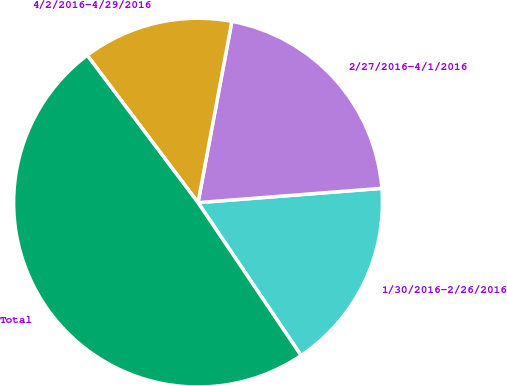Convert chart. <chart><loc_0><loc_0><loc_500><loc_500><pie_chart><fcel>1/30/2016-2/26/2016<fcel>2/27/2016-4/1/2016<fcel>4/2/2016-4/29/2016<fcel>Total<nl><fcel>16.8%<fcel>20.83%<fcel>13.2%<fcel>49.18%<nl></chart> 